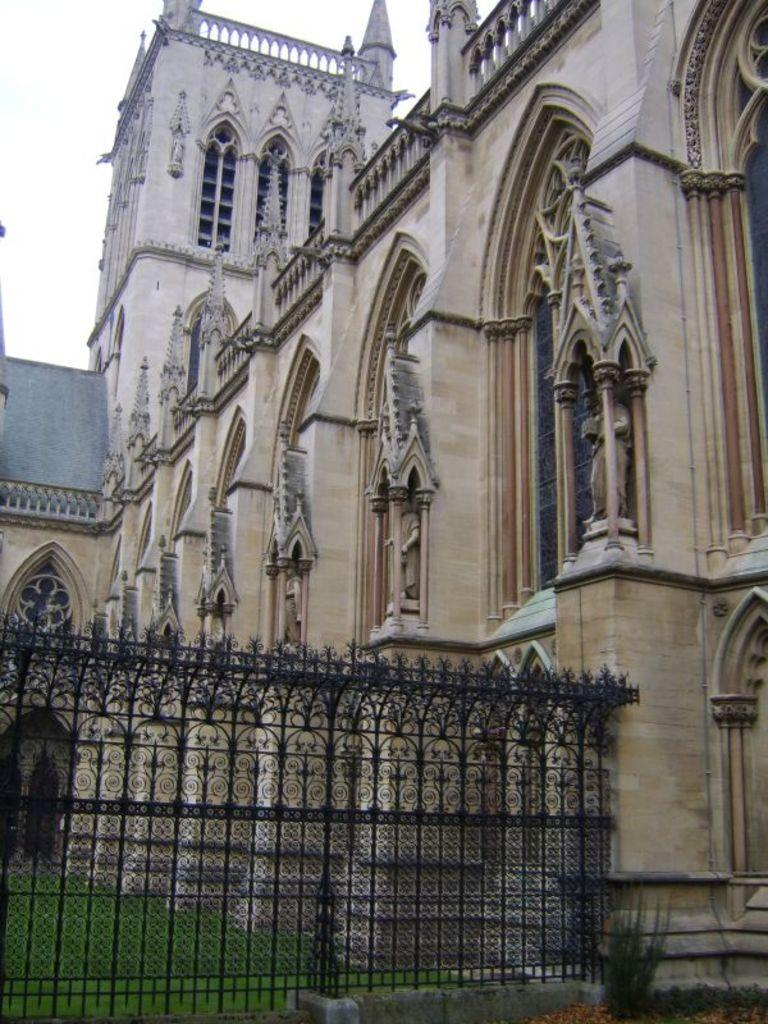What type of structure is present in the image? There is a building in the image. What type of material is used for the railing in the image? There is a metal railing in the image. What type of vegetation is visible in the image? There is grass visible in the image. What is visible in the background of the image? The sky is visible in the background of the image. What arithmetic problem is being solved on the building in the image? There is no arithmetic problem visible on the building in the image. What type of event is taking place in the image? There is no event taking place in the image; it is a static scene. What type of utensil is being used to eat a meal in the image? There is no utensil or meal present in the image. 